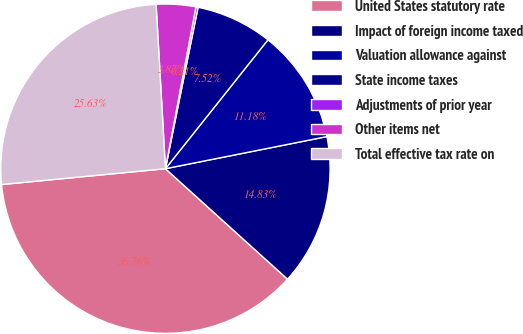<chart> <loc_0><loc_0><loc_500><loc_500><pie_chart><fcel>United States statutory rate<fcel>Impact of foreign income taxed<fcel>Valuation allowance against<fcel>State income taxes<fcel>Adjustments of prior year<fcel>Other items net<fcel>Total effective tax rate on<nl><fcel>36.76%<fcel>14.83%<fcel>11.18%<fcel>7.52%<fcel>0.21%<fcel>3.87%<fcel>25.63%<nl></chart> 